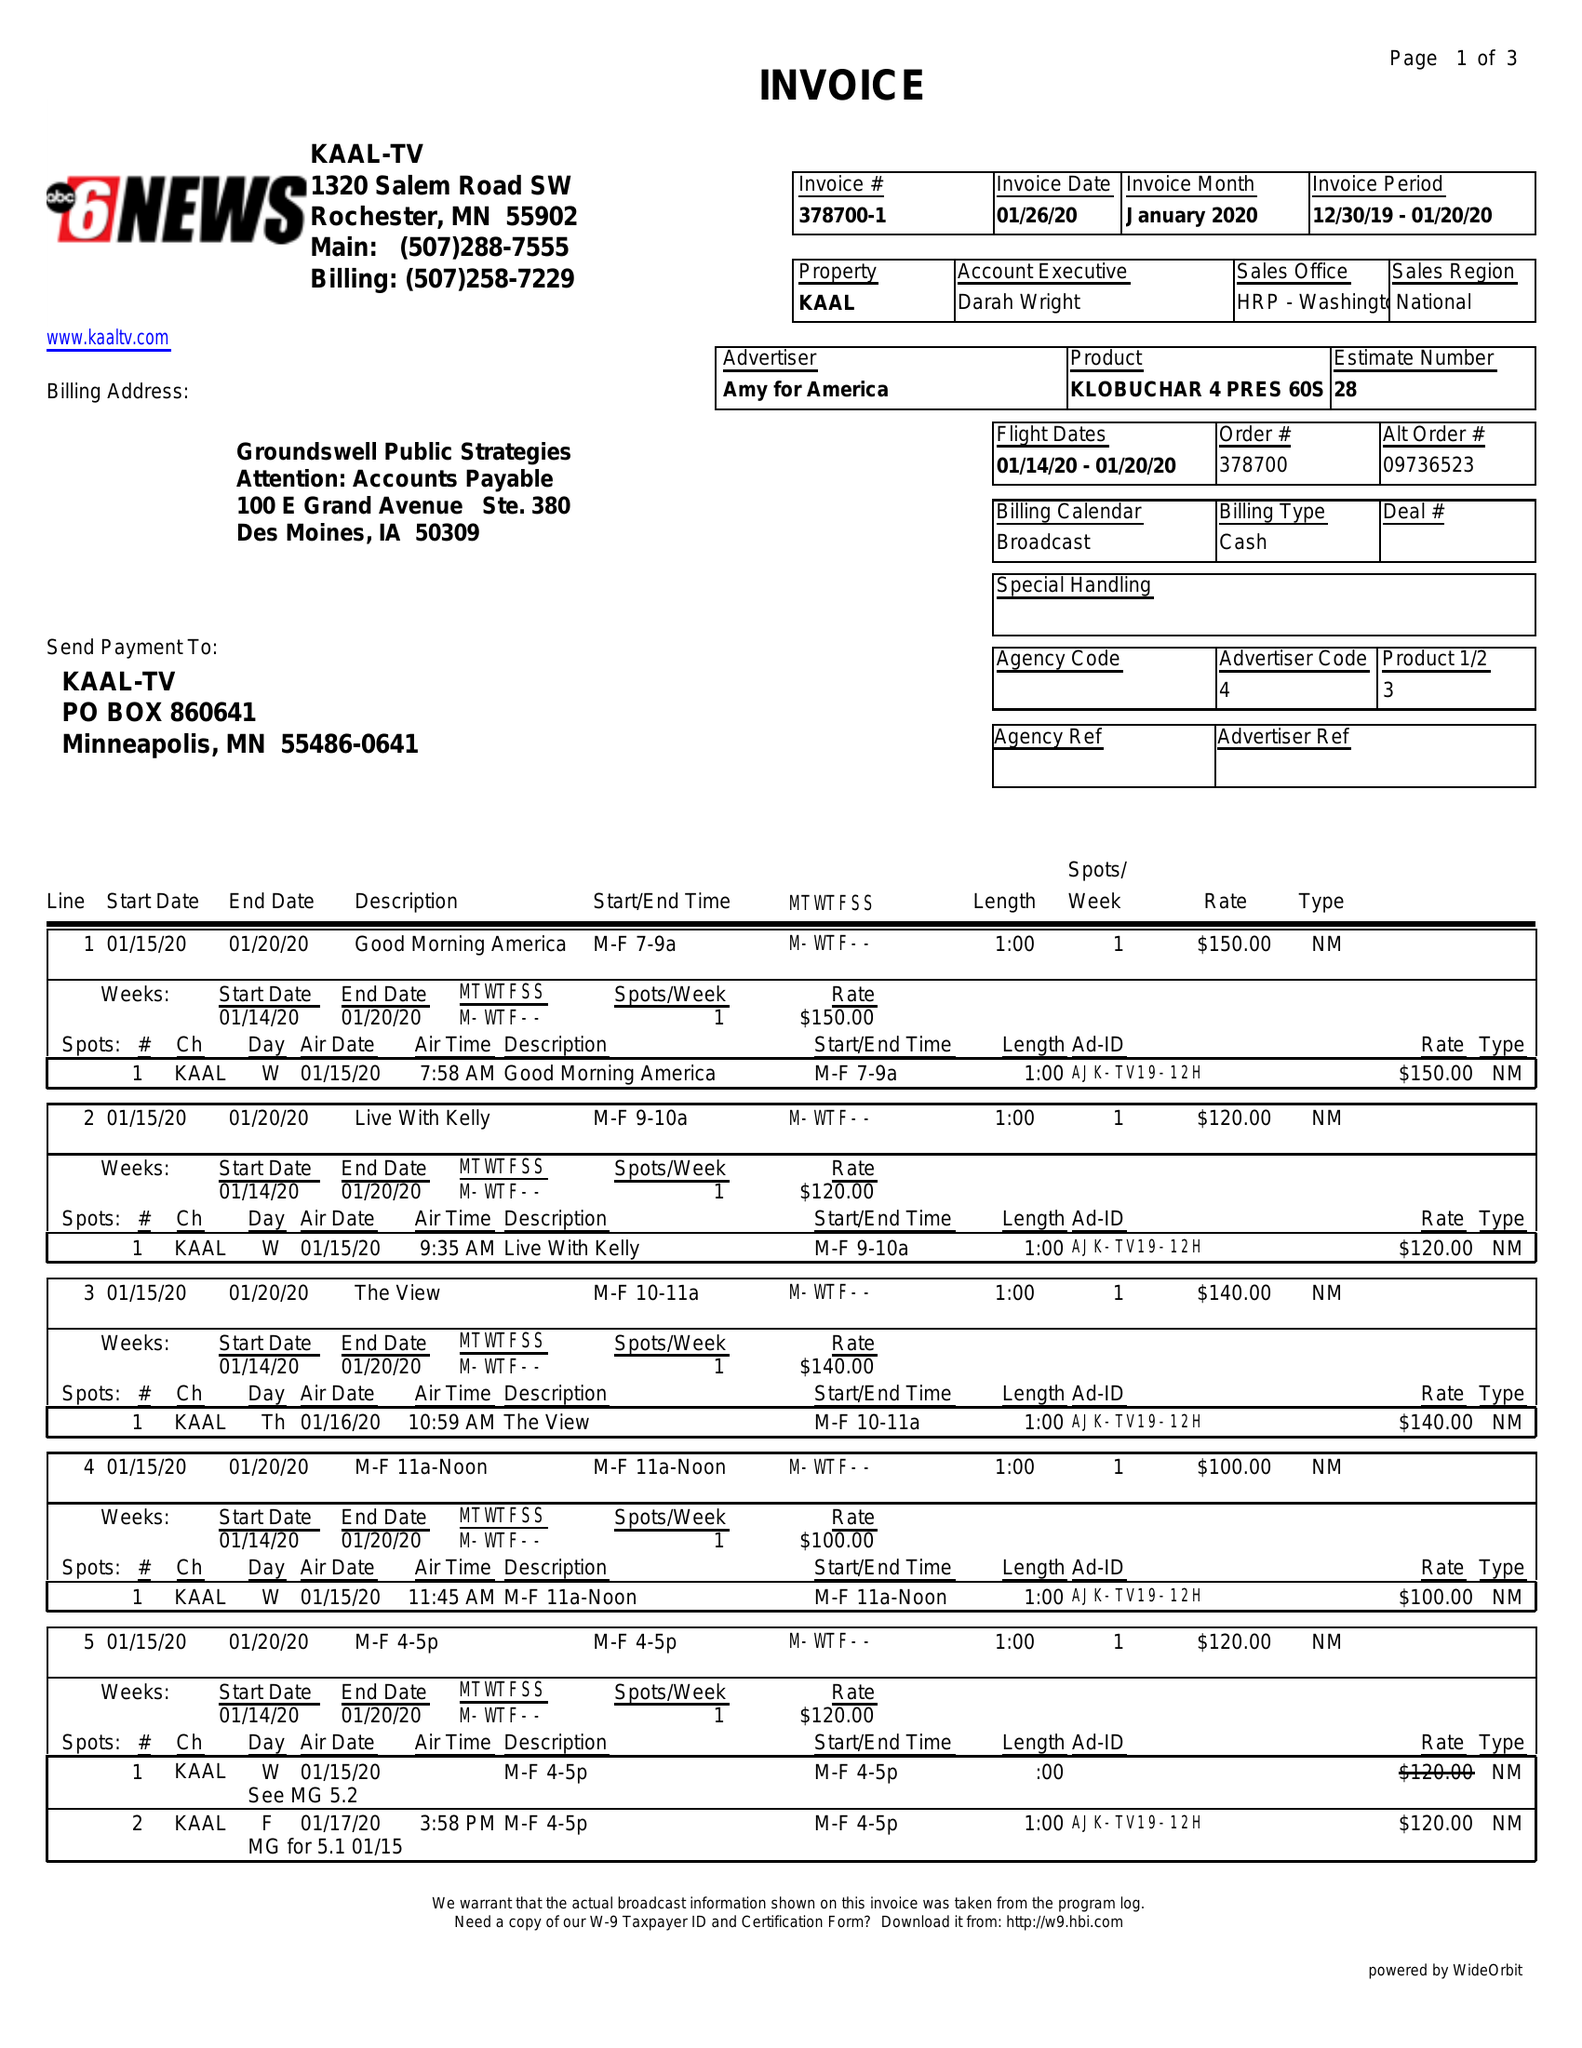What is the value for the flight_to?
Answer the question using a single word or phrase. 01/20/20 